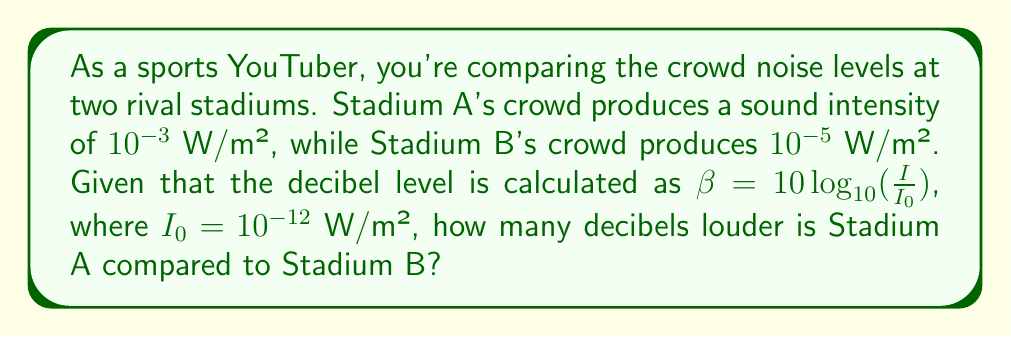Can you answer this question? Let's approach this step-by-step:

1) First, we need to calculate the decibel levels for both stadiums using the given formula:
   $\beta = 10 \log_{10}(\frac{I}{I_0})$

2) For Stadium A:
   $\beta_A = 10 \log_{10}(\frac{10^{-3}}{10^{-12}})$
   $= 10 \log_{10}(10^9) = 10 \cdot 9 = 90$ dB

3) For Stadium B:
   $\beta_B = 10 \log_{10}(\frac{10^{-5}}{10^{-12}})$
   $= 10 \log_{10}(10^7) = 10 \cdot 7 = 70$ dB

4) To find how many decibels louder Stadium A is, we subtract:
   Difference = $\beta_A - \beta_B = 90 - 70 = 20$ dB

Therefore, Stadium A is 20 decibels louder than Stadium B.
Answer: 20 dB 